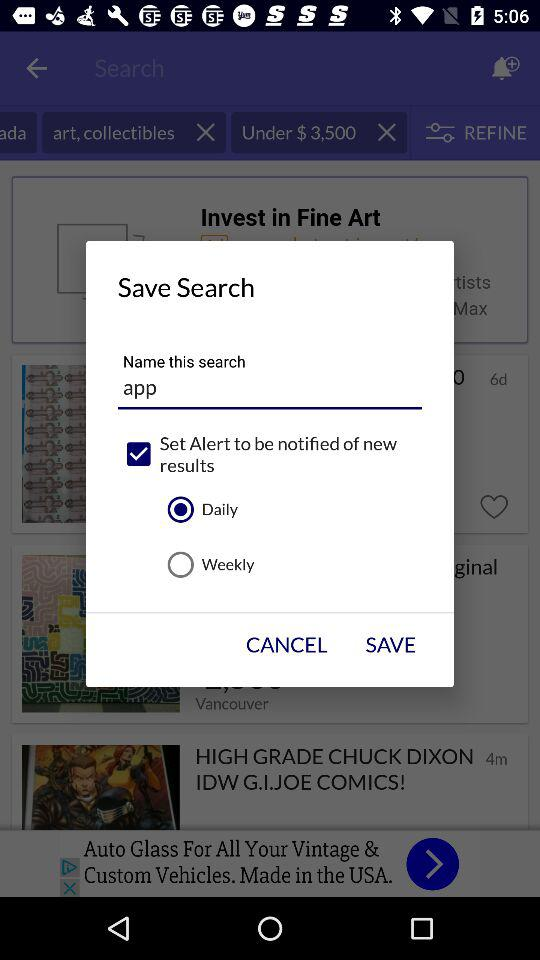How many books are there? There are 184,788 books. 